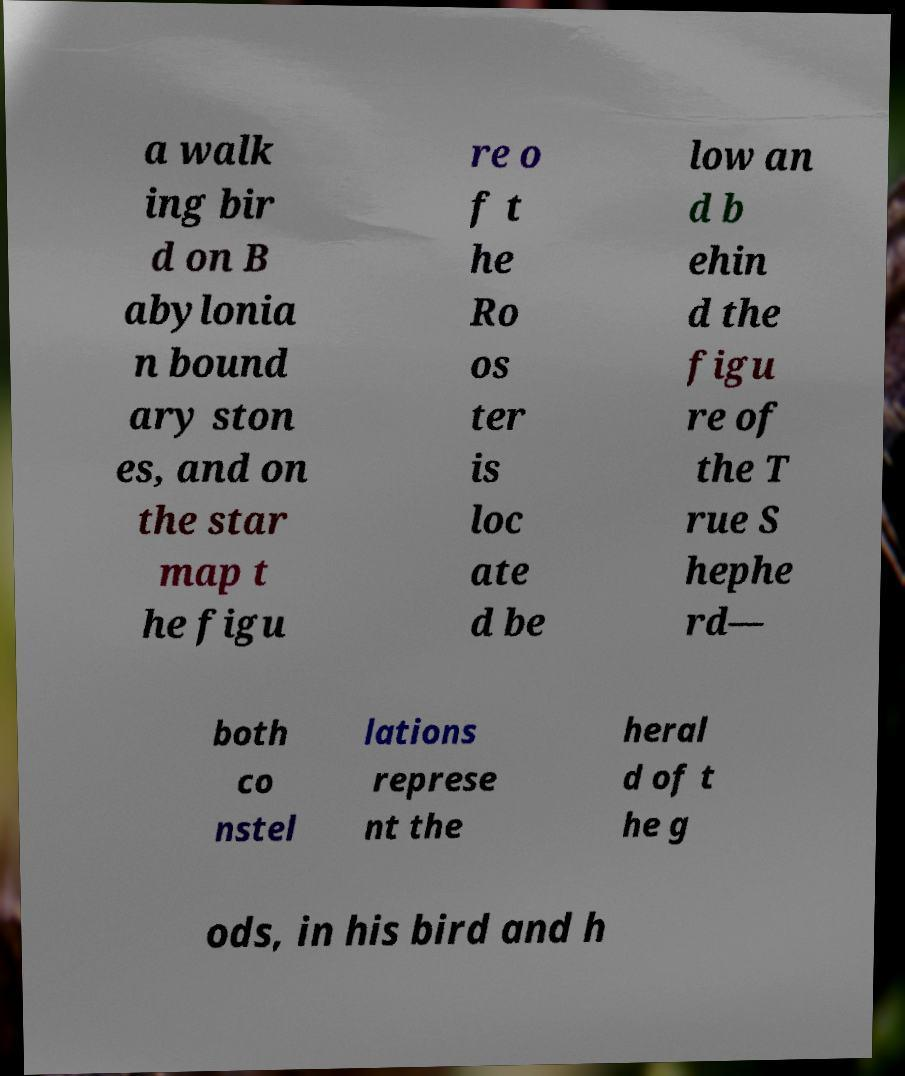Can you accurately transcribe the text from the provided image for me? a walk ing bir d on B abylonia n bound ary ston es, and on the star map t he figu re o f t he Ro os ter is loc ate d be low an d b ehin d the figu re of the T rue S hephe rd— both co nstel lations represe nt the heral d of t he g ods, in his bird and h 